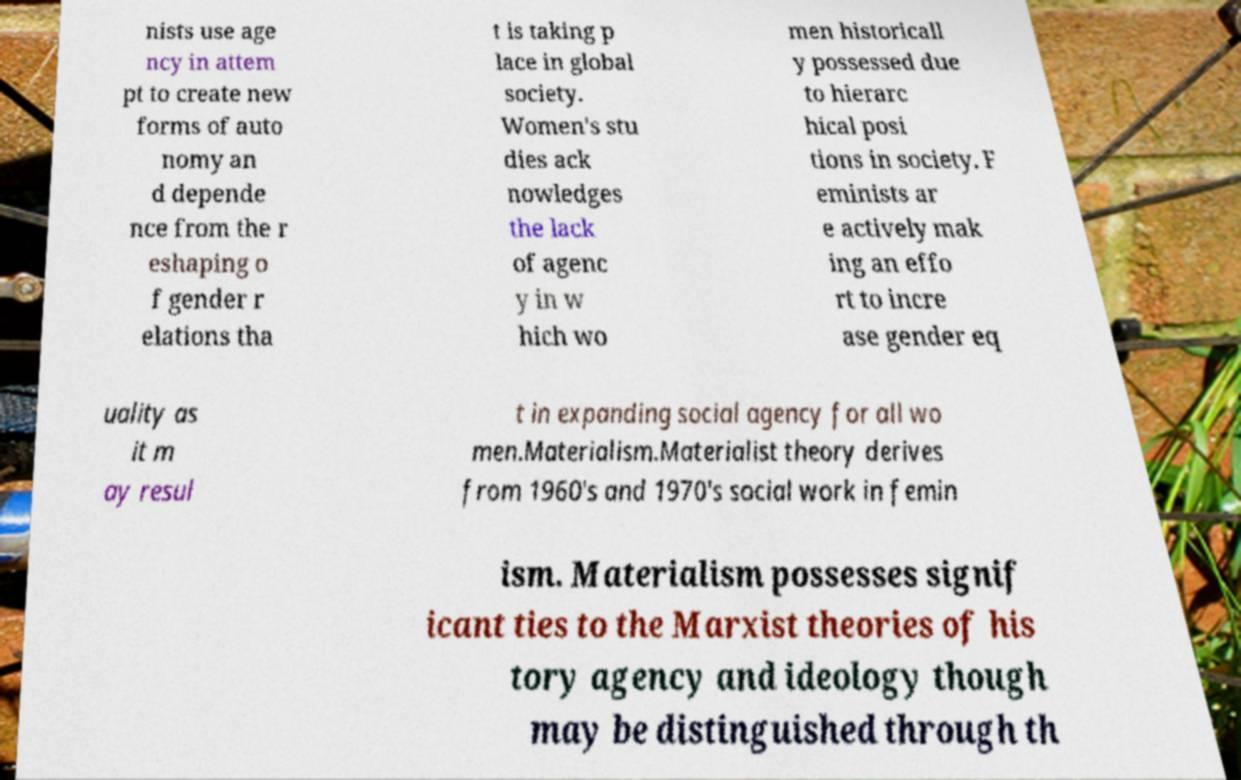What messages or text are displayed in this image? I need them in a readable, typed format. nists use age ncy in attem pt to create new forms of auto nomy an d depende nce from the r eshaping o f gender r elations tha t is taking p lace in global society. Women's stu dies ack nowledges the lack of agenc y in w hich wo men historicall y possessed due to hierarc hical posi tions in society. F eminists ar e actively mak ing an effo rt to incre ase gender eq uality as it m ay resul t in expanding social agency for all wo men.Materialism.Materialist theory derives from 1960's and 1970's social work in femin ism. Materialism possesses signif icant ties to the Marxist theories of his tory agency and ideology though may be distinguished through th 